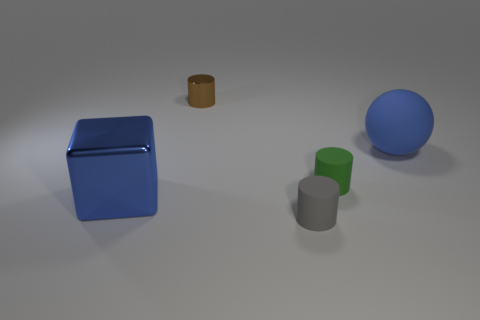Is the number of small cylinders behind the large blue rubber object less than the number of tiny yellow things?
Provide a short and direct response. No. What number of other things are the same shape as the gray object?
Make the answer very short. 2. Is there anything else that is the same color as the metal block?
Give a very brief answer. Yes. There is a cube; does it have the same color as the tiny rubber cylinder that is in front of the big blue metal cube?
Your answer should be compact. No. How many other things are there of the same size as the blue cube?
Your answer should be very brief. 1. There is a object that is the same color as the block; what is its size?
Your response must be concise. Large. How many balls are brown things or gray things?
Your response must be concise. 0. Is the shape of the big blue object left of the gray rubber object the same as  the green object?
Offer a very short reply. No. Are there more large metal blocks on the left side of the green object than big spheres?
Provide a succinct answer. No. What color is the metallic thing that is the same size as the gray cylinder?
Keep it short and to the point. Brown. 